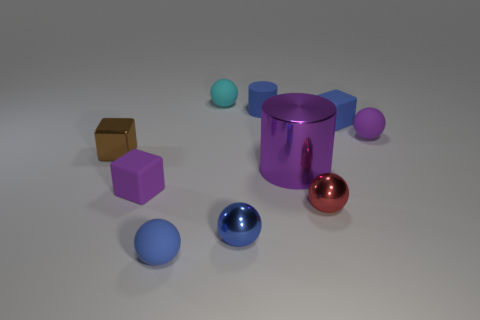Subtract all tiny purple blocks. How many blocks are left? 2 Subtract 1 cubes. How many cubes are left? 2 Subtract all small blue matte balls. Subtract all gray shiny cubes. How many objects are left? 9 Add 3 tiny purple objects. How many tiny purple objects are left? 5 Add 3 tiny rubber blocks. How many tiny rubber blocks exist? 5 Subtract all blue balls. How many balls are left? 3 Subtract 0 yellow cubes. How many objects are left? 10 Subtract all cylinders. How many objects are left? 8 Subtract all gray balls. Subtract all blue cubes. How many balls are left? 5 Subtract all blue cylinders. How many brown cubes are left? 1 